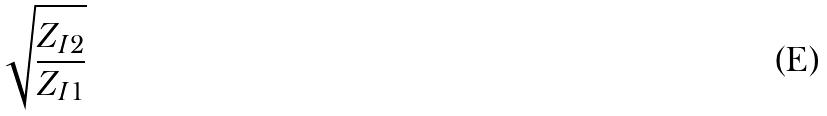Convert formula to latex. <formula><loc_0><loc_0><loc_500><loc_500>\sqrt { \frac { Z _ { I 2 } } { Z _ { I 1 } } }</formula> 